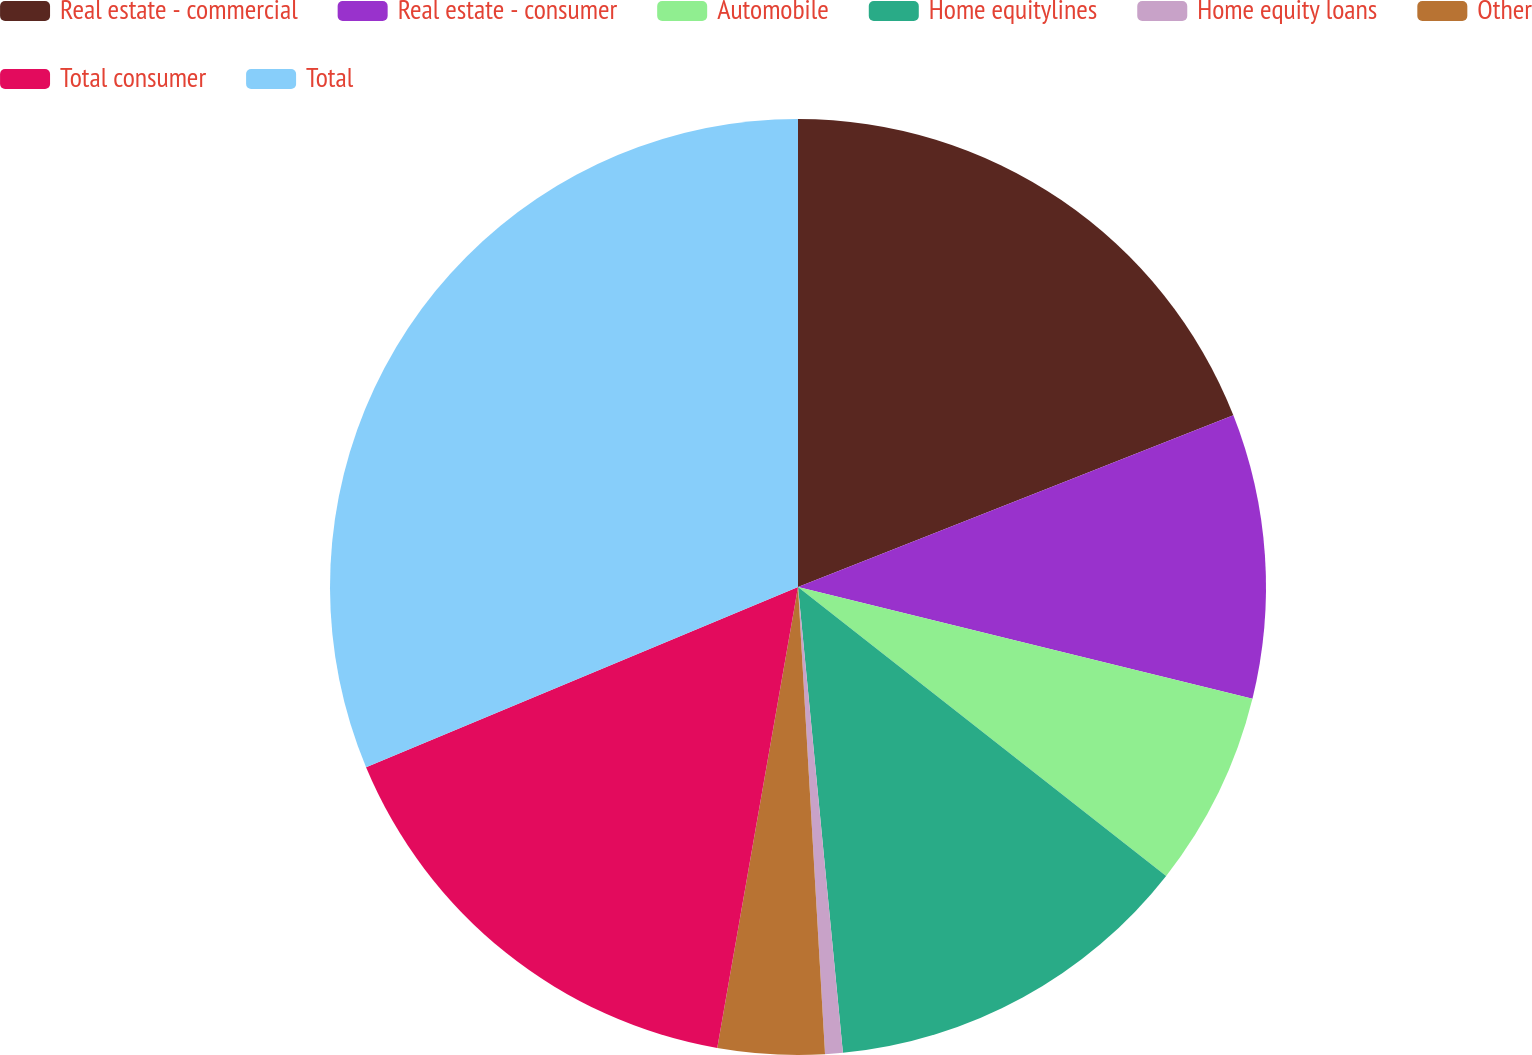Convert chart to OTSL. <chart><loc_0><loc_0><loc_500><loc_500><pie_chart><fcel>Real estate - commercial<fcel>Real estate - consumer<fcel>Automobile<fcel>Home equitylines<fcel>Home equity loans<fcel>Other<fcel>Total consumer<fcel>Total<nl><fcel>19.02%<fcel>9.82%<fcel>6.75%<fcel>12.88%<fcel>0.61%<fcel>3.68%<fcel>15.95%<fcel>31.29%<nl></chart> 